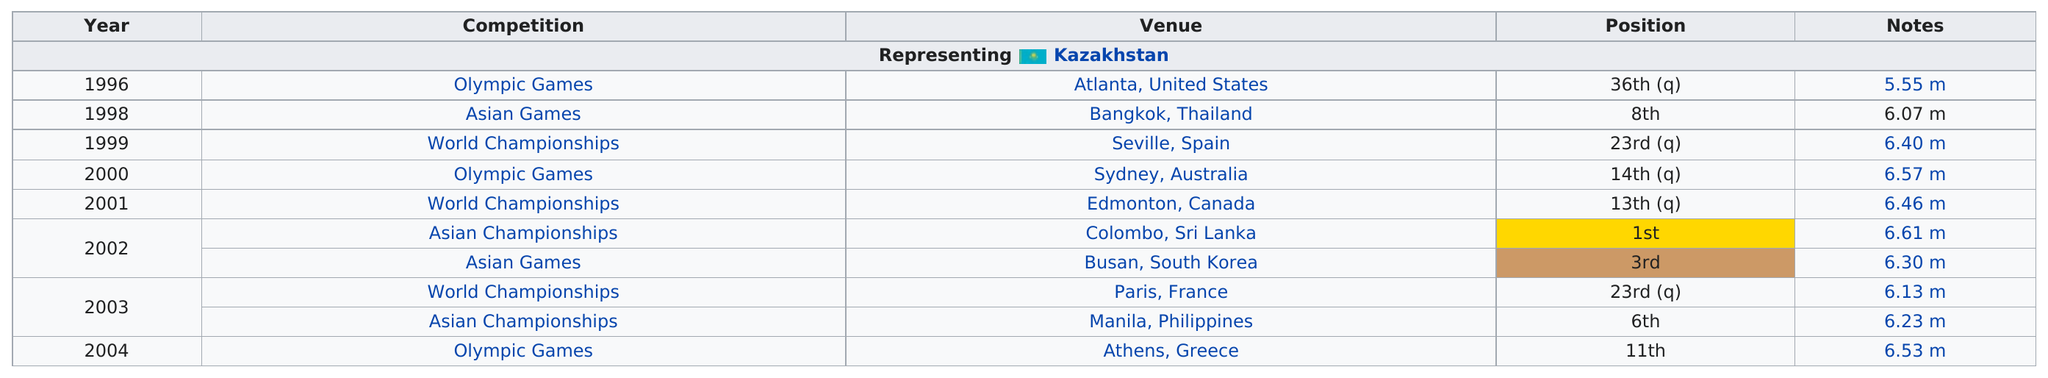Mention a couple of crucial points in this snapshot. It is known that two competitions were held in 2002. In 2003, there were 2 competitions held. I declare that Kazakhstan had the only competition where it achieved a first-place position, which was at the Asian Championships. After the 1996 Atlanta Olympic Games, the best position achieved was 11th. According to the chart, the last competition was held in Athens, Greece. 